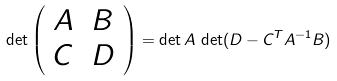<formula> <loc_0><loc_0><loc_500><loc_500>\det \left ( \begin{array} { l l } A & B \\ C & D \end{array} \right ) = \det A \, \det ( D - C ^ { T } A ^ { - 1 } B )</formula> 